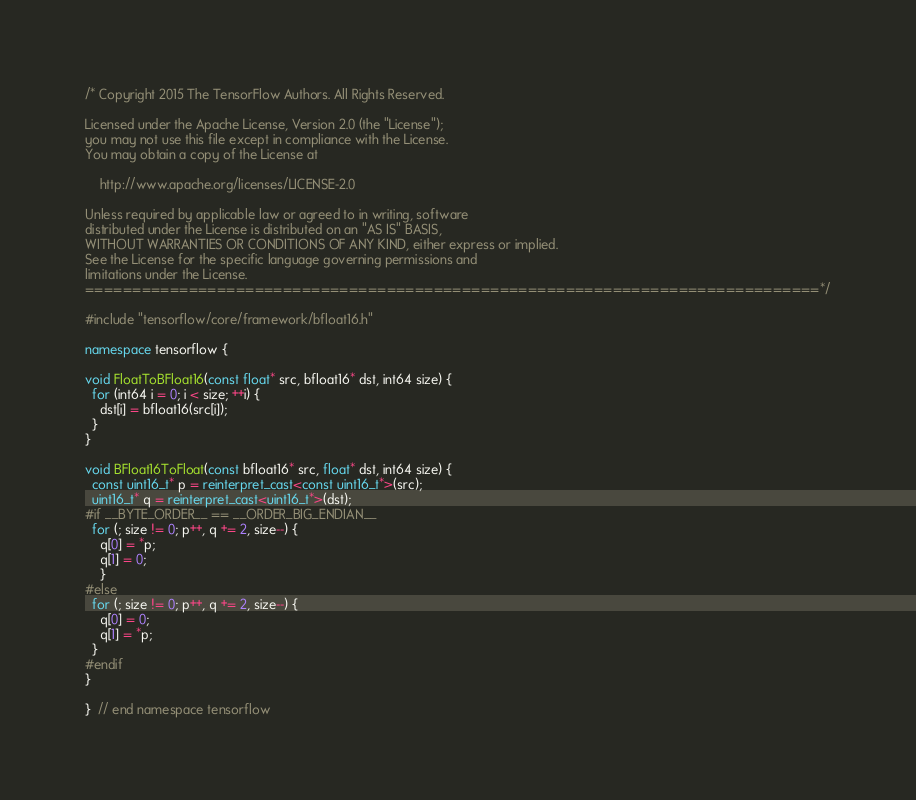<code> <loc_0><loc_0><loc_500><loc_500><_C++_>/* Copyright 2015 The TensorFlow Authors. All Rights Reserved.

Licensed under the Apache License, Version 2.0 (the "License");
you may not use this file except in compliance with the License.
You may obtain a copy of the License at

    http://www.apache.org/licenses/LICENSE-2.0

Unless required by applicable law or agreed to in writing, software
distributed under the License is distributed on an "AS IS" BASIS,
WITHOUT WARRANTIES OR CONDITIONS OF ANY KIND, either express or implied.
See the License for the specific language governing permissions and
limitations under the License.
==============================================================================*/

#include "tensorflow/core/framework/bfloat16.h"

namespace tensorflow {

void FloatToBFloat16(const float* src, bfloat16* dst, int64 size) {
  for (int64 i = 0; i < size; ++i) {
    dst[i] = bfloat16(src[i]);
  }
}

void BFloat16ToFloat(const bfloat16* src, float* dst, int64 size) {
  const uint16_t* p = reinterpret_cast<const uint16_t*>(src);
  uint16_t* q = reinterpret_cast<uint16_t*>(dst);
#if __BYTE_ORDER__ == __ORDER_BIG_ENDIAN__
  for (; size != 0; p++, q += 2, size--) {
    q[0] = *p;
    q[1] = 0;
    }
#else
  for (; size != 0; p++, q += 2, size--) {
    q[0] = 0;
    q[1] = *p;
  }
#endif
}

}  // end namespace tensorflow
</code> 